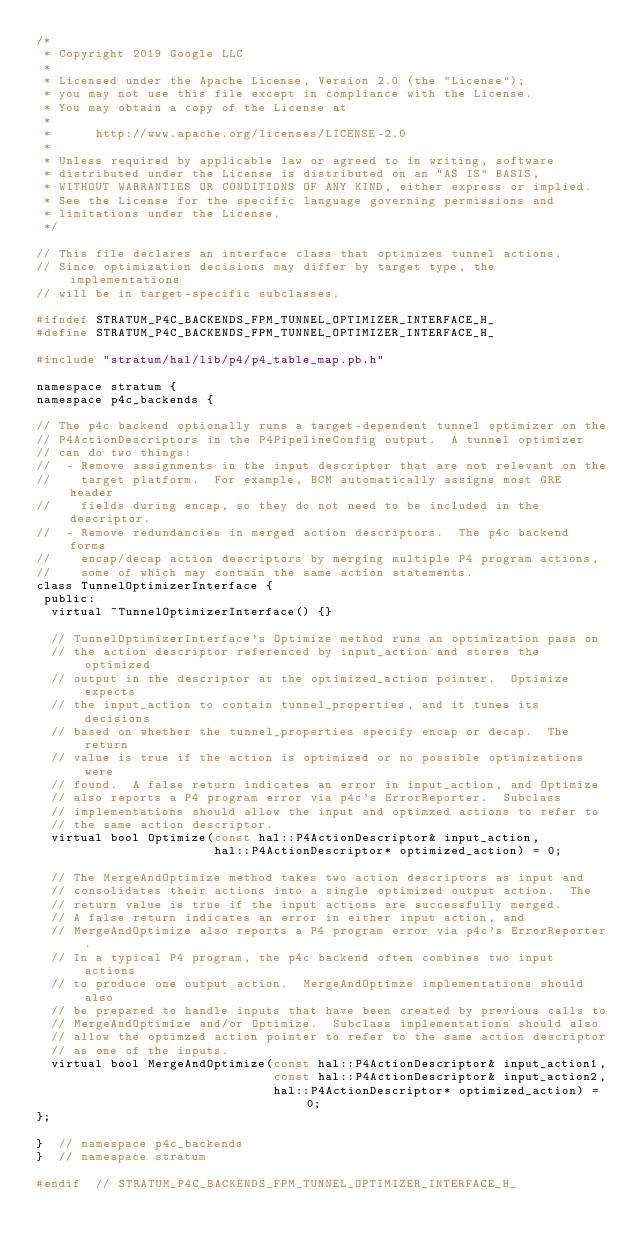Convert code to text. <code><loc_0><loc_0><loc_500><loc_500><_C_>/*
 * Copyright 2019 Google LLC
 *
 * Licensed under the Apache License, Version 2.0 (the "License");
 * you may not use this file except in compliance with the License.
 * You may obtain a copy of the License at
 *
 *      http://www.apache.org/licenses/LICENSE-2.0
 *
 * Unless required by applicable law or agreed to in writing, software
 * distributed under the License is distributed on an "AS IS" BASIS,
 * WITHOUT WARRANTIES OR CONDITIONS OF ANY KIND, either express or implied.
 * See the License for the specific language governing permissions and
 * limitations under the License.
 */

// This file declares an interface class that optimizes tunnel actions.
// Since optimization decisions may differ by target type, the implementations
// will be in target-specific subclasses.

#ifndef STRATUM_P4C_BACKENDS_FPM_TUNNEL_OPTIMIZER_INTERFACE_H_
#define STRATUM_P4C_BACKENDS_FPM_TUNNEL_OPTIMIZER_INTERFACE_H_

#include "stratum/hal/lib/p4/p4_table_map.pb.h"

namespace stratum {
namespace p4c_backends {

// The p4c backend optionally runs a target-dependent tunnel optimizer on the
// P4ActionDescriptors in the P4PipelineConfig output.  A tunnel optimizer
// can do two things:
//  - Remove assignments in the input descriptor that are not relevant on the
//    target platform.  For example, BCM automatically assigns most GRE header
//    fields during encap, so they do not need to be included in the descriptor.
//  - Remove redundancies in merged action descriptors.  The p4c backend forms
//    encap/decap action descriptors by merging multiple P4 program actions,
//    some of which may contain the same action statements.
class TunnelOptimizerInterface {
 public:
  virtual ~TunnelOptimizerInterface() {}

  // TunnelOptimizerInterface's Optimize method runs an optimization pass on
  // the action descriptor referenced by input_action and stores the optimized
  // output in the descriptor at the optimized_action pointer.  Optimize expects
  // the input_action to contain tunnel_properties, and it tunes its decisions
  // based on whether the tunnel_properties specify encap or decap.  The return
  // value is true if the action is optimized or no possible optimizations were
  // found.  A false return indicates an error in input_action, and Optimize
  // also reports a P4 program error via p4c's ErrorReporter.  Subclass
  // implementations should allow the input and optimzed actions to refer to
  // the same action descriptor.
  virtual bool Optimize(const hal::P4ActionDescriptor& input_action,
                        hal::P4ActionDescriptor* optimized_action) = 0;

  // The MergeAndOptimize method takes two action descriptors as input and
  // consolidates their actions into a single optimized output action.  The
  // return value is true if the input actions are successfully merged.
  // A false return indicates an error in either input action, and
  // MergeAndOptimize also reports a P4 program error via p4c's ErrorReporter.
  // In a typical P4 program, the p4c backend often combines two input actions
  // to produce one output action.  MergeAndOptimze implementations should also
  // be prepared to handle inputs that have been created by previous calls to
  // MergeAndOptimize and/or Optimize.  Subclass implementations should also
  // allow the optimzed action pointer to refer to the same action descriptor
  // as one of the inputs.
  virtual bool MergeAndOptimize(const hal::P4ActionDescriptor& input_action1,
                                const hal::P4ActionDescriptor& input_action2,
                                hal::P4ActionDescriptor* optimized_action) = 0;
};

}  // namespace p4c_backends
}  // namespace stratum

#endif  // STRATUM_P4C_BACKENDS_FPM_TUNNEL_OPTIMIZER_INTERFACE_H_
</code> 